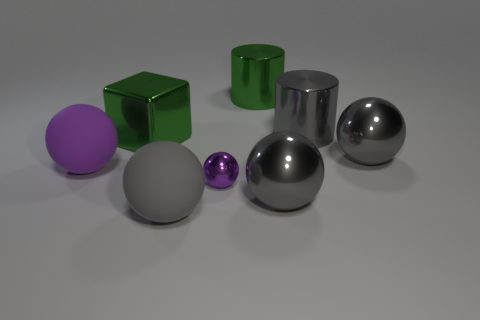What could be the purpose of arranging these objects like this? The arrangement of these objects could serve several purposes. It may be an artistic composition intended to showcase contrast in colors and shapes, a demonstration for a 3D rendering software highlighting shading and lighting effects, or even a setting for a photography lesson on reflections and textures. The diversity in sizes and materials invites the viewer to consider the interplay of light and form in space. 